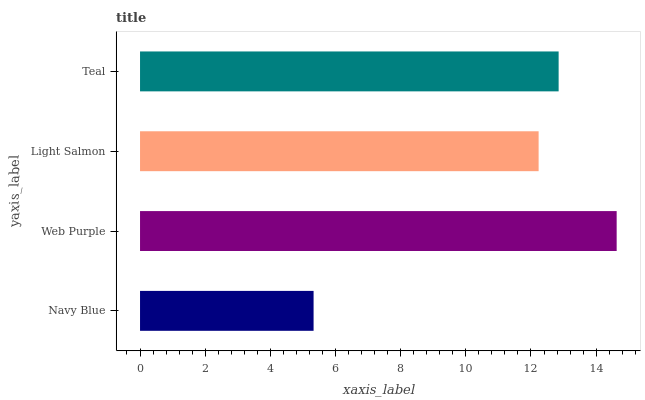Is Navy Blue the minimum?
Answer yes or no. Yes. Is Web Purple the maximum?
Answer yes or no. Yes. Is Light Salmon the minimum?
Answer yes or no. No. Is Light Salmon the maximum?
Answer yes or no. No. Is Web Purple greater than Light Salmon?
Answer yes or no. Yes. Is Light Salmon less than Web Purple?
Answer yes or no. Yes. Is Light Salmon greater than Web Purple?
Answer yes or no. No. Is Web Purple less than Light Salmon?
Answer yes or no. No. Is Teal the high median?
Answer yes or no. Yes. Is Light Salmon the low median?
Answer yes or no. Yes. Is Light Salmon the high median?
Answer yes or no. No. Is Teal the low median?
Answer yes or no. No. 